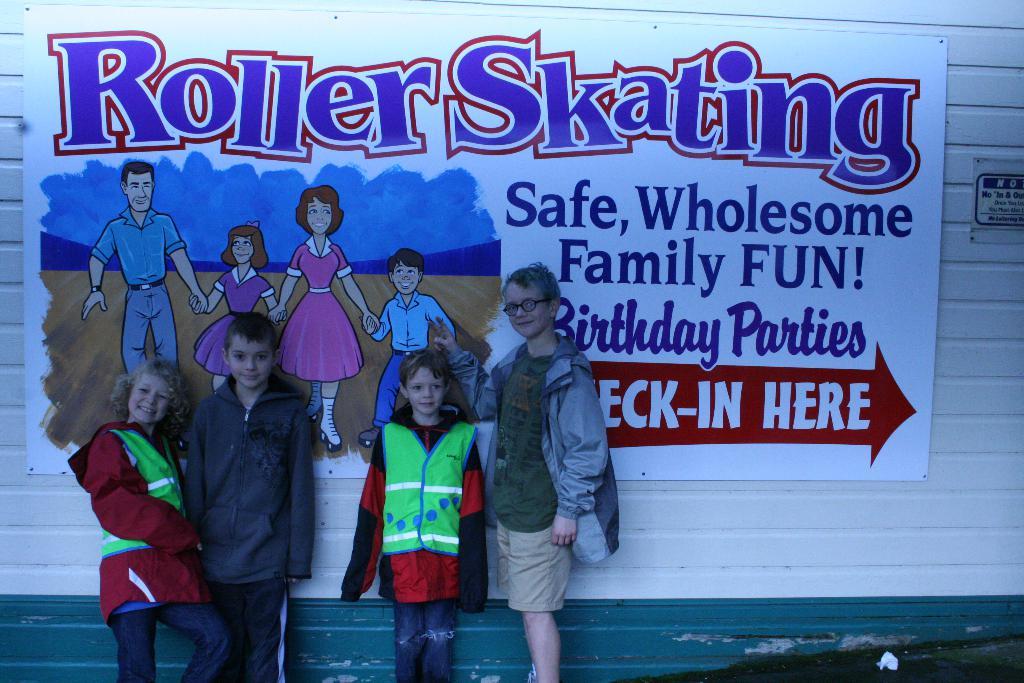What kind of party can you have at the rink?
Offer a terse response. Birthday. What kind of skating is here?
Your answer should be compact. Roller. 